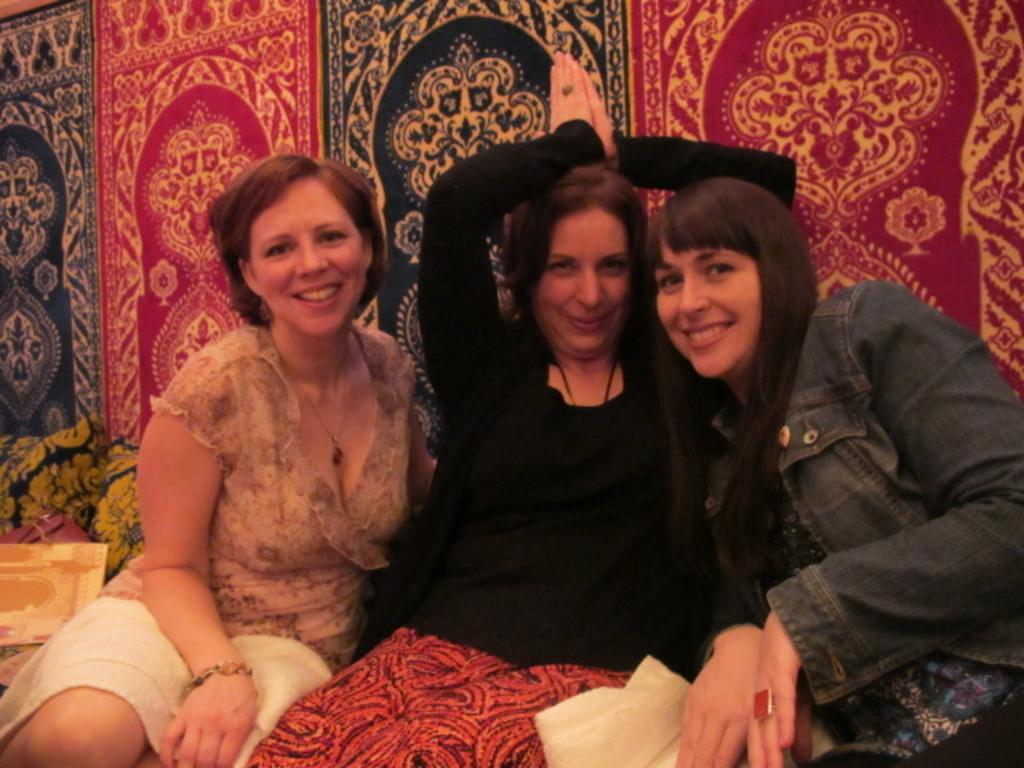How many people are in the image? There are three women in the image. What is the facial expression of the women? The women are smiling. What can be seen in the background of the image? There is a mattress in the background of the image. What type of grass is growing on the net in the image? There is no grass or net present in the image; it features three women who are smiling. 